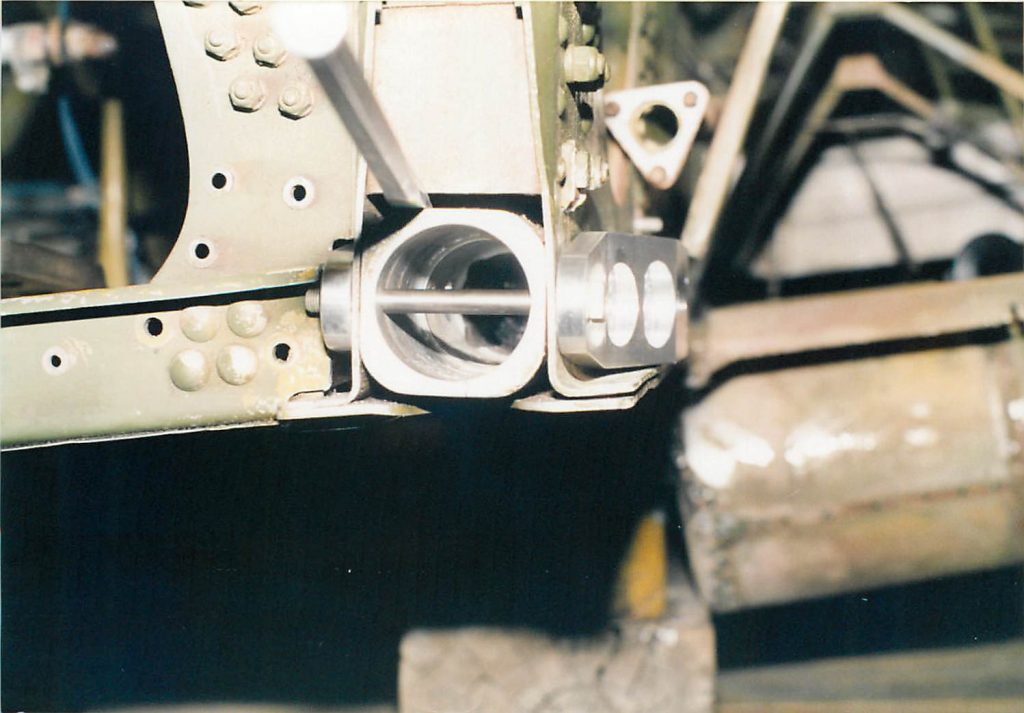What might be the function of the grooves machined into the cylindrical pin? The grooves machined into the cylindrical pin are primarily designed to facilitate a locking mechanism or to hold lubrication effectively. Such grooves enhance the pin’s operation within its mechanical assembly by preventing slippage and ensuring it stays in an optimal position. In applications where the pin is part of a dynamic structure, like in aircraft landing gear, these grooves could house a locking clip or retaining wire, ensuring robust stability under stress. Additionally, they serve to evenly distribute lubricant across the contact surfaces, reducing friction and wear, crucial for maintaining the longevity and efficiency of high-performance mechanical systems. 